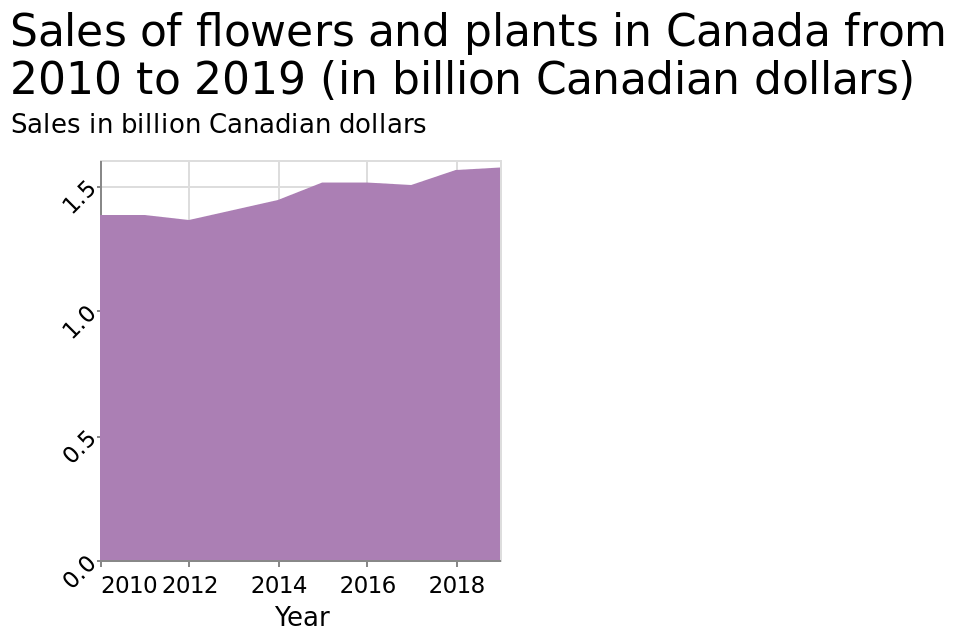<image>
Offer a thorough analysis of the image. That sales of flowers have gone up from 2010 to 2019 in Canada. What does the y-axis represent in the area diagram?  The y-axis represents sales in billion Canadian dollars. What is the trend in flower sales in Canada over the past 8 years?  The trend in flower sales in Canada over the past 8 years has been a gradual increase. Has there been any fluctuations in flower sales in Canada over the last 8 years?  No, flower sales in Canada have been consistently increasing over the last 8 years. What is the highest value reached by sales in the area diagram?  The area diagram does not provide information on the highest value reached by sales. It only shows the sales trend over the years. 